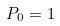<formula> <loc_0><loc_0><loc_500><loc_500>P _ { 0 } = 1</formula> 